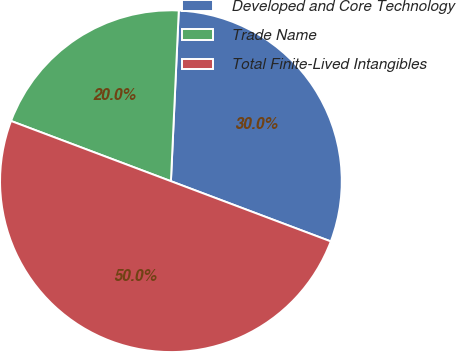Convert chart to OTSL. <chart><loc_0><loc_0><loc_500><loc_500><pie_chart><fcel>Developed and Core Technology<fcel>Trade Name<fcel>Total Finite-Lived Intangibles<nl><fcel>30.0%<fcel>20.0%<fcel>50.0%<nl></chart> 